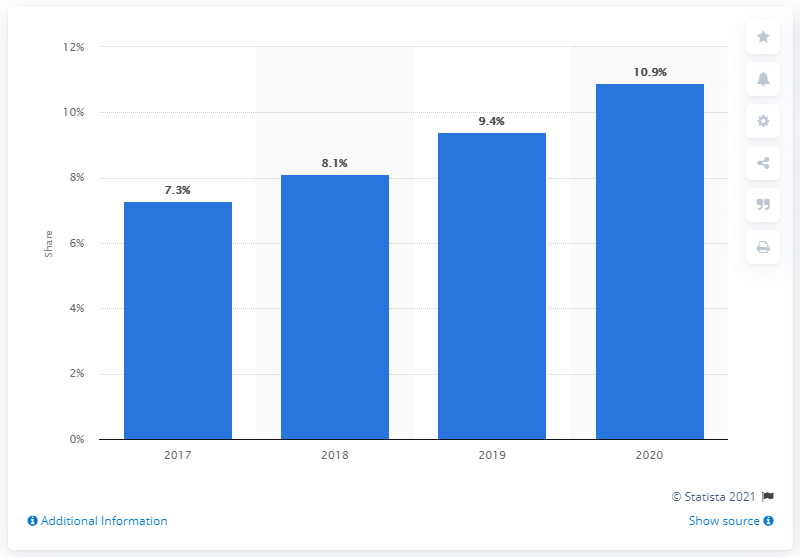Point out several critical features in this image. In 2020, YouTube generated approximately 10.9% of Google's total revenue. 